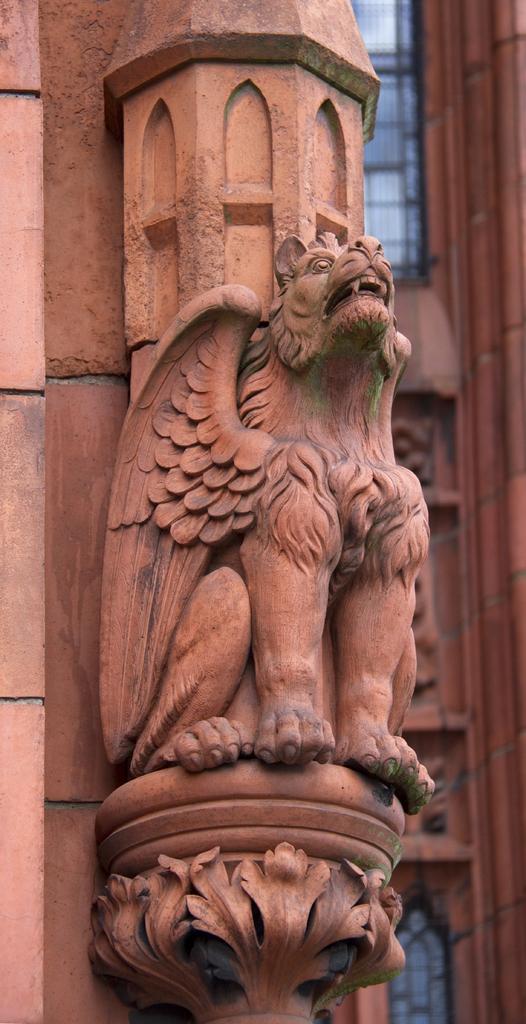Please provide a concise description of this image. In this picture we can see a sculpture and in the background we can see a building with windows. 